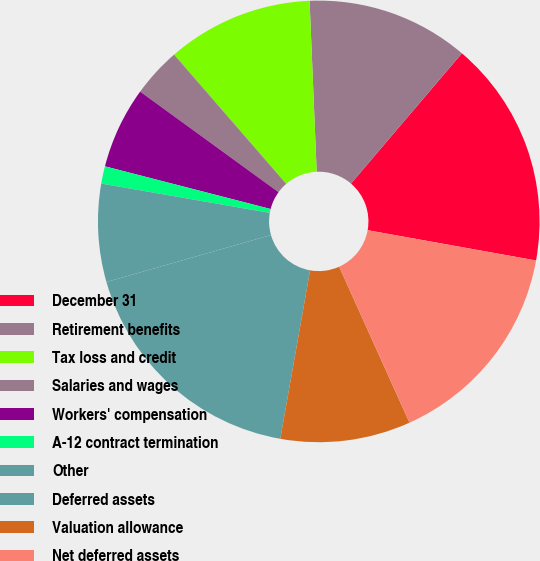Convert chart to OTSL. <chart><loc_0><loc_0><loc_500><loc_500><pie_chart><fcel>December 31<fcel>Retirement benefits<fcel>Tax loss and credit<fcel>Salaries and wages<fcel>Workers' compensation<fcel>A-12 contract termination<fcel>Other<fcel>Deferred assets<fcel>Valuation allowance<fcel>Net deferred assets<nl><fcel>16.61%<fcel>11.89%<fcel>10.71%<fcel>3.63%<fcel>5.99%<fcel>1.27%<fcel>7.17%<fcel>17.79%<fcel>9.53%<fcel>15.43%<nl></chart> 